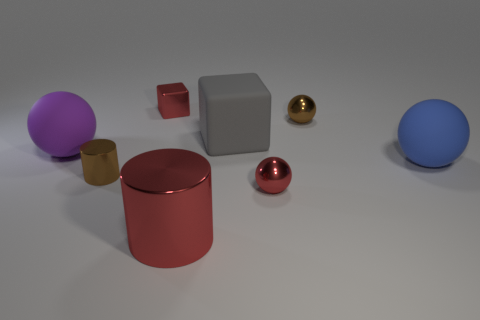How big is the shiny thing that is both behind the purple object and in front of the metal block?
Provide a short and direct response. Small. What number of gray things are in front of the small brown shiny cylinder?
Offer a very short reply. 0. There is a shiny object that is both behind the small red sphere and in front of the gray cube; what shape is it?
Your answer should be compact. Cylinder. There is a small sphere that is the same color as the big metallic object; what material is it?
Offer a terse response. Metal. What number of blocks are big rubber objects or brown metallic objects?
Make the answer very short. 1. There is a shiny ball that is the same color as the big metallic cylinder; what size is it?
Provide a succinct answer. Small. Is the number of red spheres that are in front of the big red thing less than the number of brown spheres?
Provide a succinct answer. Yes. What is the color of the thing that is both behind the big gray cube and on the right side of the red cylinder?
Ensure brevity in your answer.  Brown. How many other objects are there of the same shape as the big shiny object?
Offer a very short reply. 1. Is the number of tiny cylinders right of the shiny cube less than the number of metallic balls that are in front of the red shiny ball?
Give a very brief answer. No. 